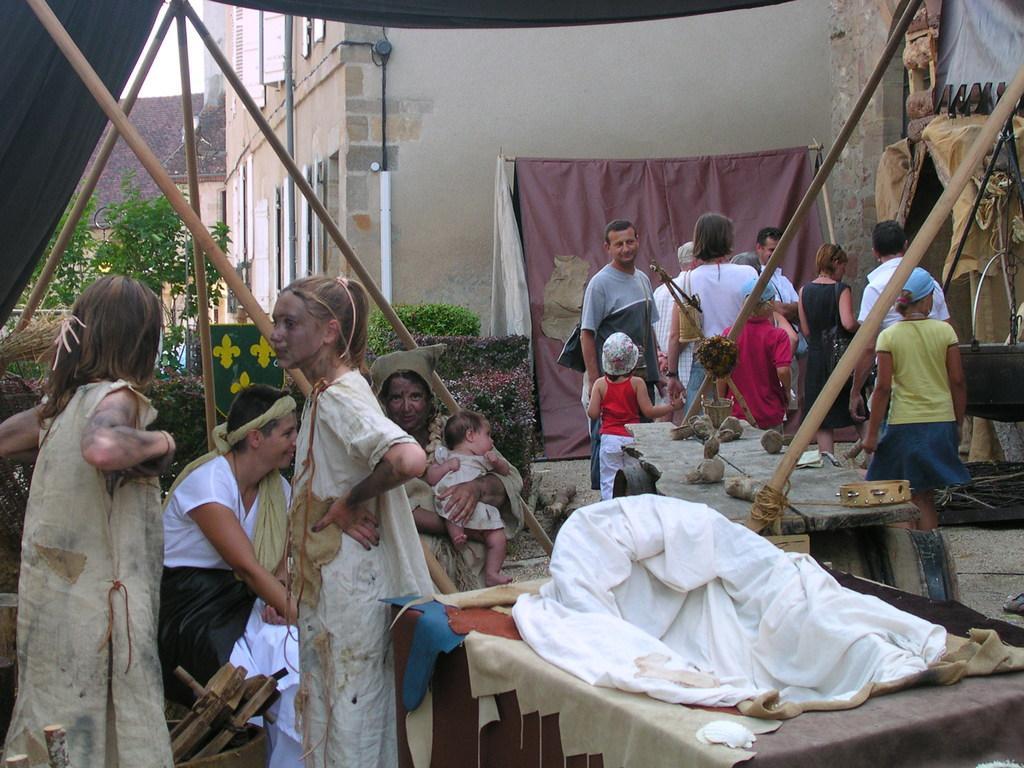Can you describe this image briefly? To the left side of the image there are people. In the background of the image there is a building. There are plants. There are people standing. To the right side of the image there are tables with objects on it. There are bamboo sticks. At the top of the image there is tent cloth. 